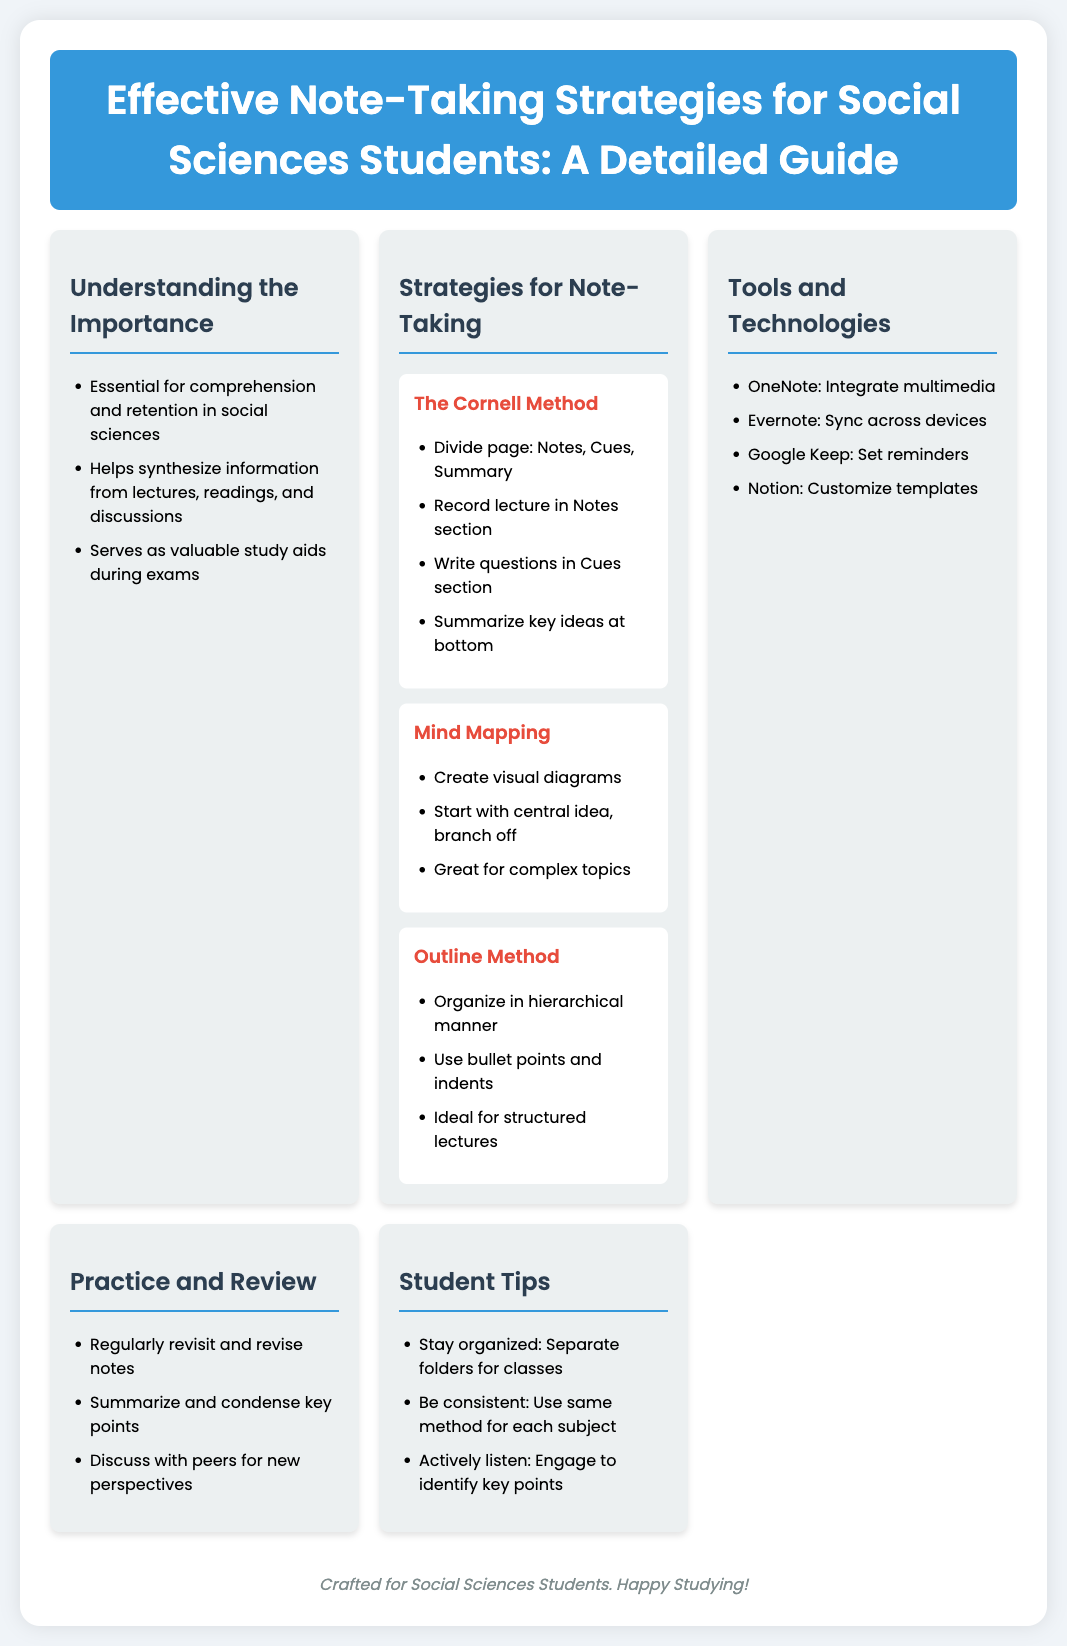What is the title of the poster? The title is prominently displayed at the top of the poster, indicating its main theme.
Answer: Effective Note-Taking Strategies for Social Sciences Students: A Detailed Guide What is one benefit of effective note-taking? This information is found in the section discussing the importance of note-taking, outlining its various advantages.
Answer: Essential for comprehension and retention in social sciences Which note-taking method involves dividing a page into three sections? This is mentioned under the strategies for note-taking, specifically in the Cornell Method subsection.
Answer: The Cornell Method Name a tool that helps integrate multimedia for note-taking. The tools and technologies section lists various applications for note-taking, including capabilities for multimedia.
Answer: OneNote What is critical for effective comprehension during lectures? The student tips section emphasizes key practices that enhance note-taking quality and effectiveness.
Answer: Actively listen Which note-taking method is ideal for structured lectures? This detail can be found in the subsection that describes different note-taking strategies tailored to specific lecture types.
Answer: Outline Method What should students do to enhance their learning and retention of notes? Insights on practicing and reviewing notes indicate specific actions students can take for better understanding.
Answer: Regularly revisit and revise notes 